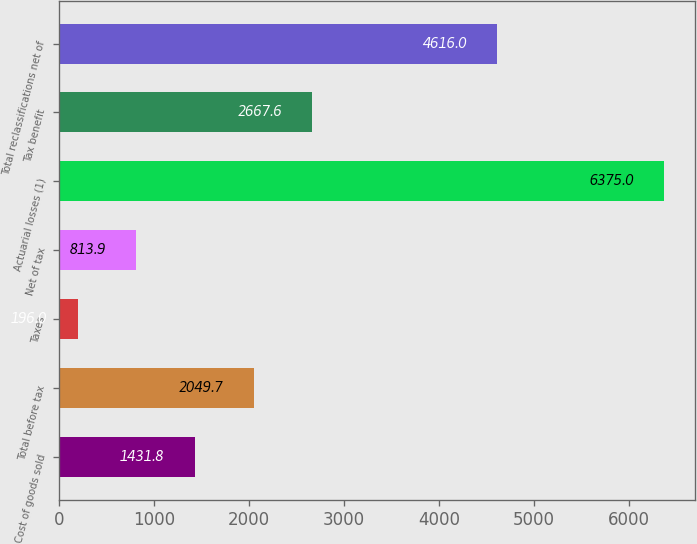<chart> <loc_0><loc_0><loc_500><loc_500><bar_chart><fcel>Cost of goods sold<fcel>Total before tax<fcel>Taxes<fcel>Net of tax<fcel>Actuarial losses (1)<fcel>Tax benefit<fcel>Total reclassifications net of<nl><fcel>1431.8<fcel>2049.7<fcel>196<fcel>813.9<fcel>6375<fcel>2667.6<fcel>4616<nl></chart> 